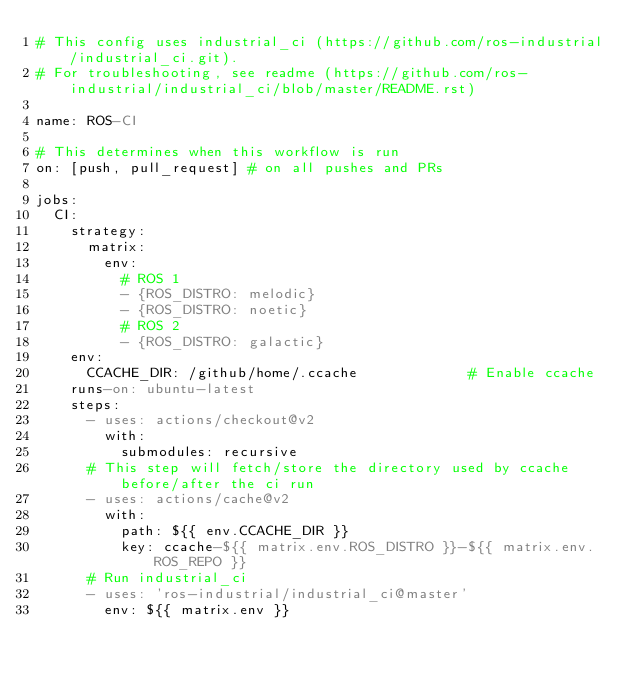Convert code to text. <code><loc_0><loc_0><loc_500><loc_500><_YAML_># This config uses industrial_ci (https://github.com/ros-industrial/industrial_ci.git).
# For troubleshooting, see readme (https://github.com/ros-industrial/industrial_ci/blob/master/README.rst)

name: ROS-CI

# This determines when this workflow is run
on: [push, pull_request] # on all pushes and PRs

jobs:
  CI:
    strategy:
      matrix:
        env:
          # ROS 1
          - {ROS_DISTRO: melodic}
          - {ROS_DISTRO: noetic}
          # ROS 2
          - {ROS_DISTRO: galactic}
    env:
      CCACHE_DIR: /github/home/.ccache             # Enable ccache
    runs-on: ubuntu-latest
    steps:
      - uses: actions/checkout@v2
        with:
          submodules: recursive
      # This step will fetch/store the directory used by ccache before/after the ci run
      - uses: actions/cache@v2
        with:
          path: ${{ env.CCACHE_DIR }}
          key: ccache-${{ matrix.env.ROS_DISTRO }}-${{ matrix.env.ROS_REPO }}
      # Run industrial_ci
      - uses: 'ros-industrial/industrial_ci@master'
        env: ${{ matrix.env }}
</code> 